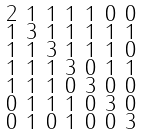<formula> <loc_0><loc_0><loc_500><loc_500>\begin{smallmatrix} 2 & 1 & 1 & 1 & 1 & 0 & 0 \\ 1 & 3 & 1 & 1 & 1 & 1 & 1 \\ 1 & 1 & 3 & 1 & 1 & 1 & 0 \\ 1 & 1 & 1 & 3 & 0 & 1 & 1 \\ 1 & 1 & 1 & 0 & 3 & 0 & 0 \\ 0 & 1 & 1 & 1 & 0 & 3 & 0 \\ 0 & 1 & 0 & 1 & 0 & 0 & 3 \end{smallmatrix}</formula> 